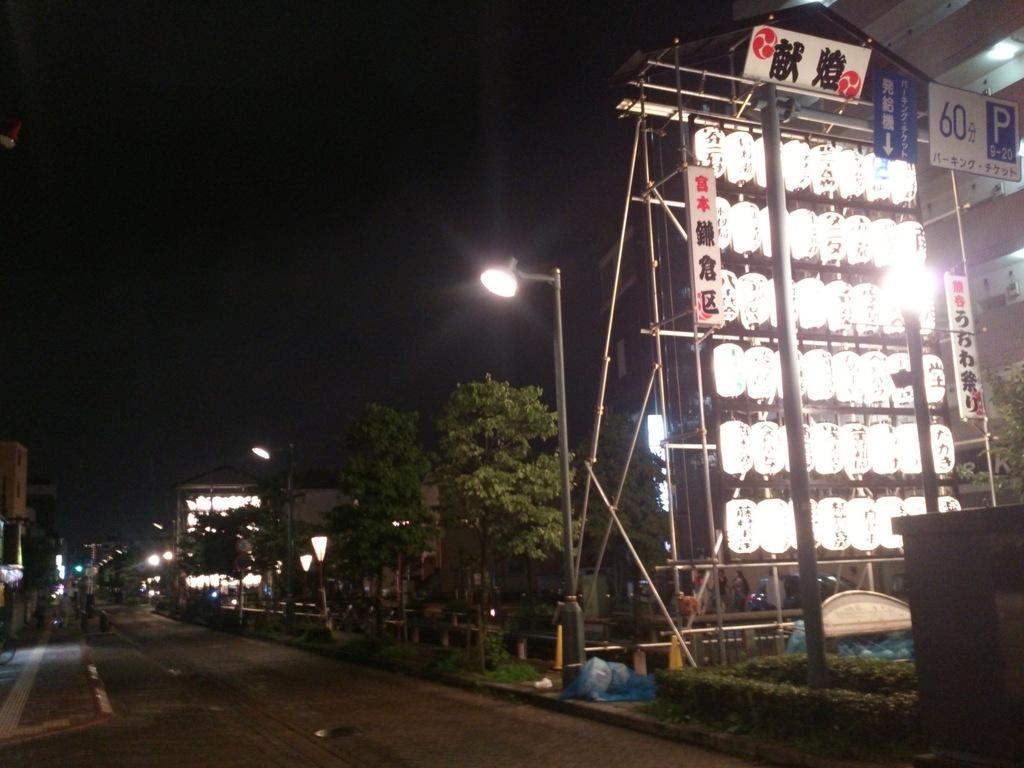Provide a one-sentence caption for the provided image. "60" and "P 9-20" can be seen in the upper corner of a bank of lights near a dark street. 